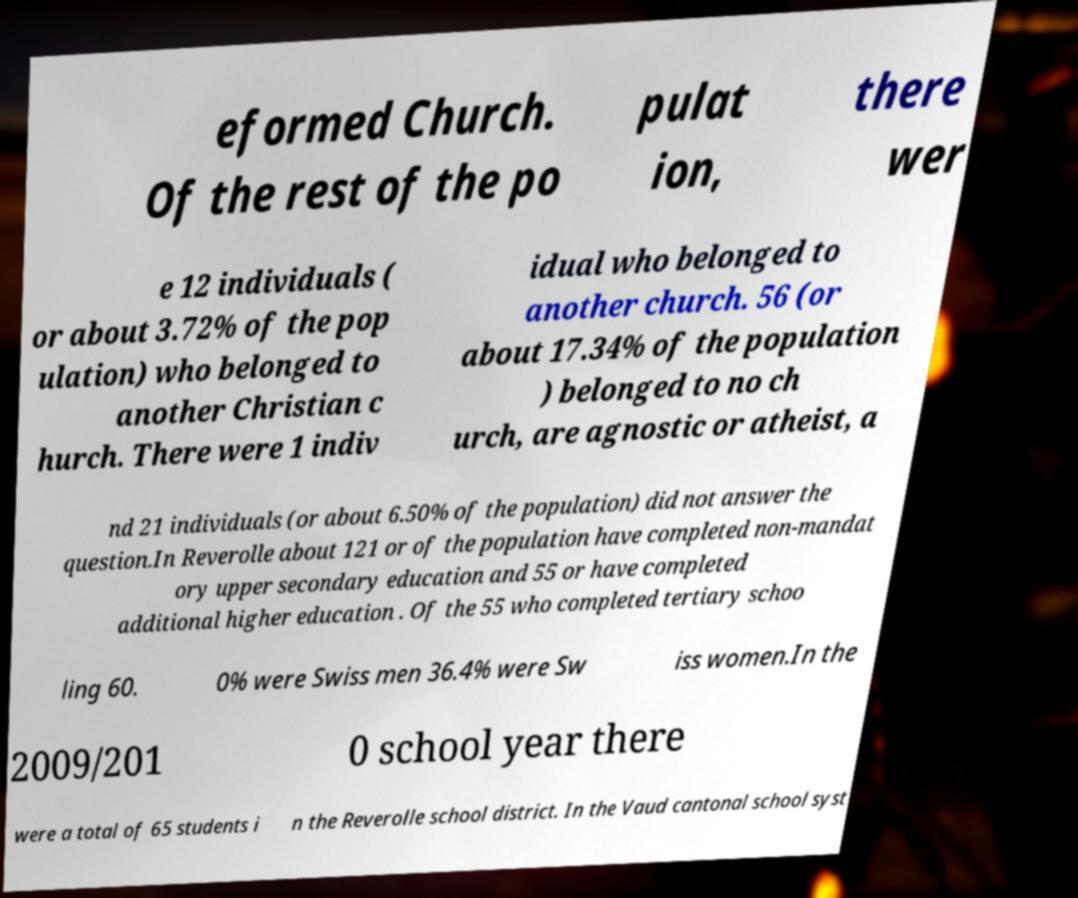For documentation purposes, I need the text within this image transcribed. Could you provide that? eformed Church. Of the rest of the po pulat ion, there wer e 12 individuals ( or about 3.72% of the pop ulation) who belonged to another Christian c hurch. There were 1 indiv idual who belonged to another church. 56 (or about 17.34% of the population ) belonged to no ch urch, are agnostic or atheist, a nd 21 individuals (or about 6.50% of the population) did not answer the question.In Reverolle about 121 or of the population have completed non-mandat ory upper secondary education and 55 or have completed additional higher education . Of the 55 who completed tertiary schoo ling 60. 0% were Swiss men 36.4% were Sw iss women.In the 2009/201 0 school year there were a total of 65 students i n the Reverolle school district. In the Vaud cantonal school syst 